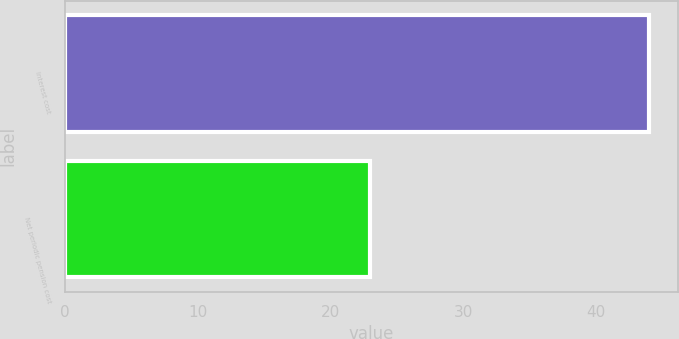Convert chart. <chart><loc_0><loc_0><loc_500><loc_500><bar_chart><fcel>Interest cost<fcel>Net periodic pension cost<nl><fcel>44<fcel>23<nl></chart> 